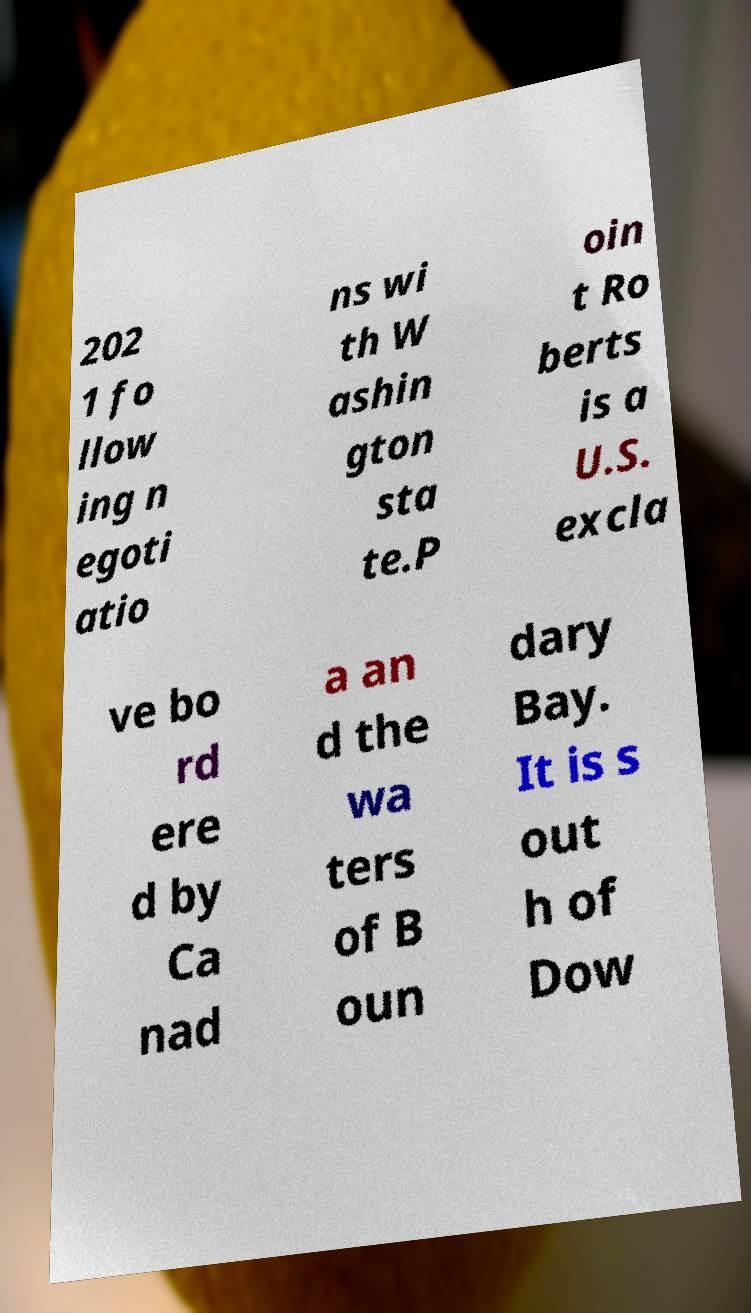Could you assist in decoding the text presented in this image and type it out clearly? 202 1 fo llow ing n egoti atio ns wi th W ashin gton sta te.P oin t Ro berts is a U.S. excla ve bo rd ere d by Ca nad a an d the wa ters of B oun dary Bay. It is s out h of Dow 